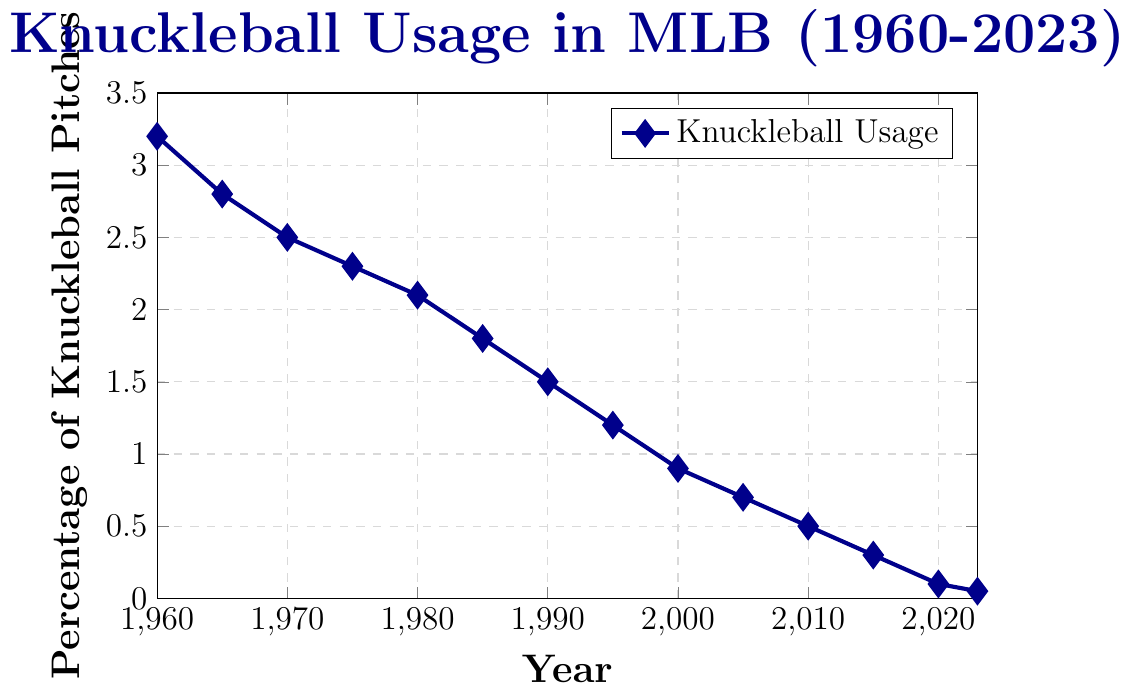What is the highest percentage of knuckleball pitches shown on the chart? The highest percentage appears in the year 1960. Checking the y-axis value for that year, it is 3.2%.
Answer: 3.2% Which year saw the lowest percentage of knuckleball pitches? The lowest percentage can be identified at the rightmost point on the chart. Checking the year, it is 2023 with a percentage of 0.05%.
Answer: 2023 By how much did the knuckleball pitch percentage decrease from 1960 to 2023? Finding the values for 1960 and 2023, the decrease is calculated as 3.2% (1960) - 0.05% (2023) = 3.15%.
Answer: 3.15% In which decade did the percentage of knuckleball pitches drop below 1%? Observing the points on the chart, the percentage dropped below 1% between 1995 (1.2%) and 2000 (0.9%). Both years are in the 1990s.
Answer: 1990s What is the percentage difference in knuckleball pitch usage between 1980 and 2000? The value for 1980 is 2.1%, and for 2000 is 0.9%. The percentage difference is 2.1% - 0.9% = 1.2%.
Answer: 1.2% Which year shows the steepest decline in knuckleball pitch usage compared to the previous recorded year? Comparing consecutive years, from 1995 (1.2%) to 2000 (0.9%) shows a bigger drop of 0.3 than other intervals.
Answer: 2000 What is the average percentage of knuckleball pitches across all recorded years? Summing all values: 3.2 + 2.8 + 2.5 + 2.3 + 2.1 + 1.8 + 1.5 + 1.2 + 0.9 + 0.7 + 0.5 + 0.3 + 0.1 + 0.05 = 22.85. Dividing by 14: 22.85 / 14 ≈ 1.63%.
Answer: 1.63% When did the percentage first drop below 2%? Checking the chart, the percentage first dropped below 2% in the year 1985, where it is recorded as 1.8%.
Answer: 1985 By how much did the knuckleball pitch percentage drop from 2005 to 2015? The value in 2005 is 0.7% and in 2015 is 0.3%. The difference is 0.7% - 0.3% = 0.4%.
Answer: 0.4% Is the trend of knuckleball pitch usage increasing, decreasing, or constant over the years? Observing the line from 1960 to 2023, one can see a clear downward slope, indicating a decreasing trend.
Answer: Decreasing 